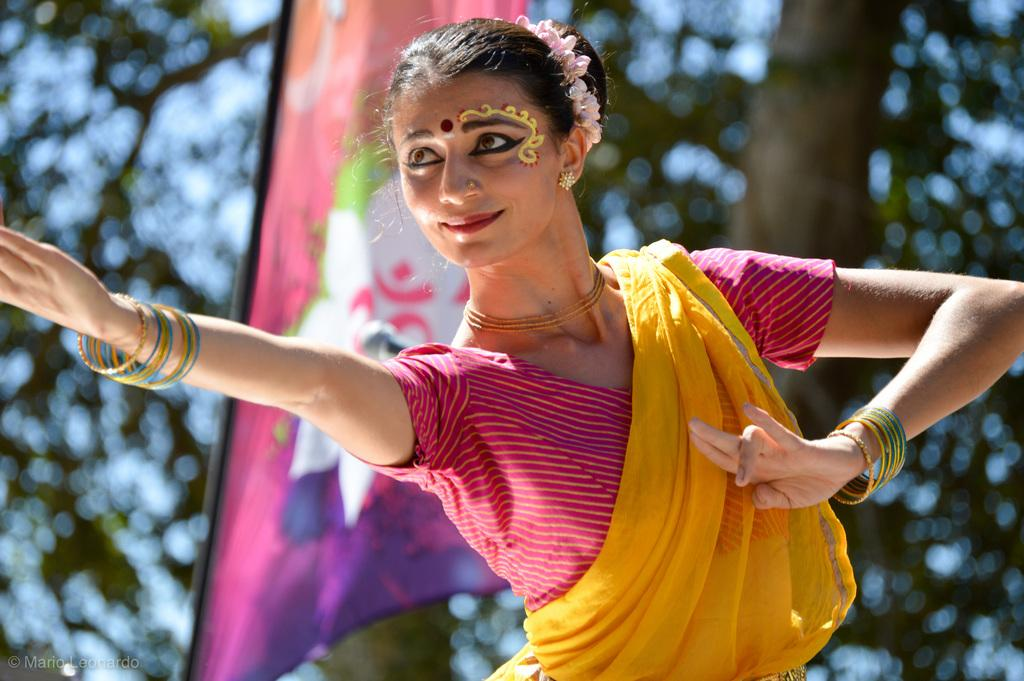Who is the main subject in the image? There is a lady in the center of the image. What is the condition of the background in the image? The background of the image is blurred. What object can be seen in the image besides the lady? There is a flag in the image. What type of toothbrush is the lady using in the image? There is no toothbrush present in the image. How does the lady pull the flag in the image? There is no indication in the image that the lady is pulling the flag. 